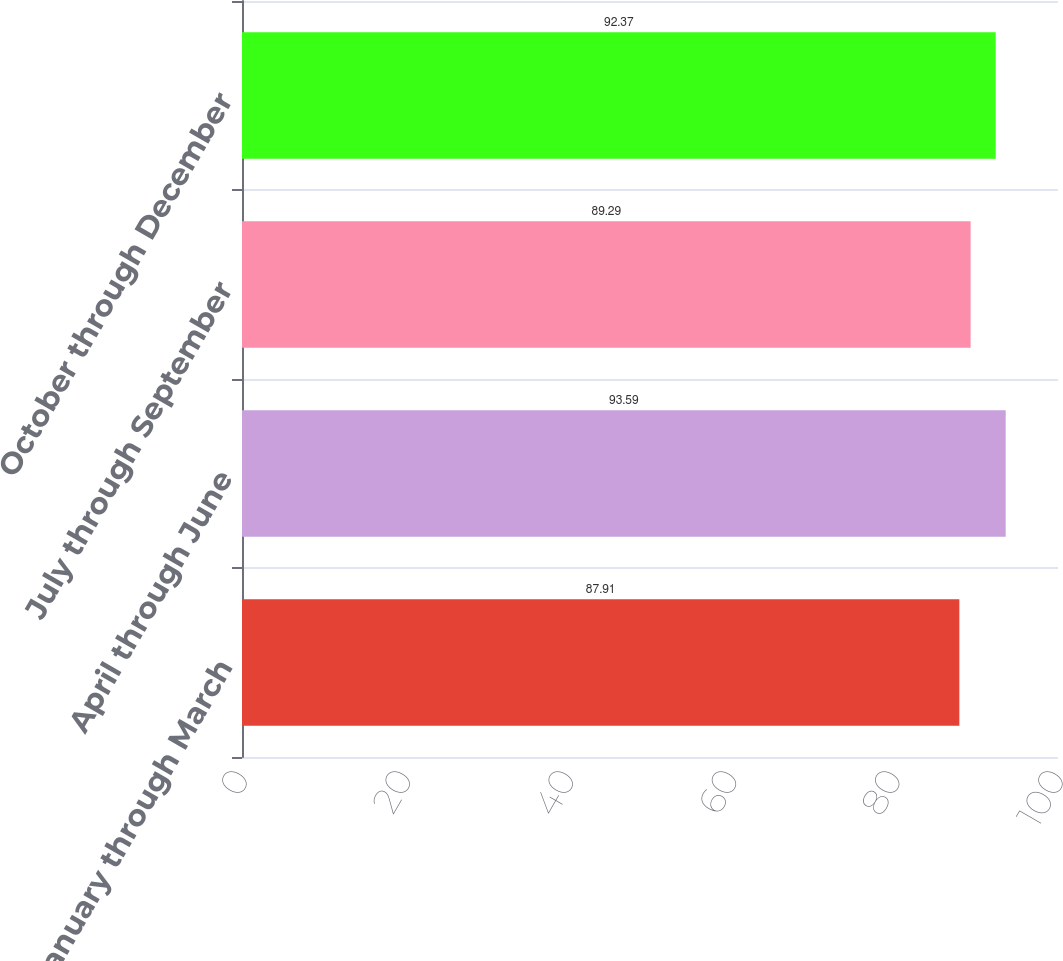Convert chart to OTSL. <chart><loc_0><loc_0><loc_500><loc_500><bar_chart><fcel>January through March<fcel>April through June<fcel>July through September<fcel>October through December<nl><fcel>87.91<fcel>93.59<fcel>89.29<fcel>92.37<nl></chart> 